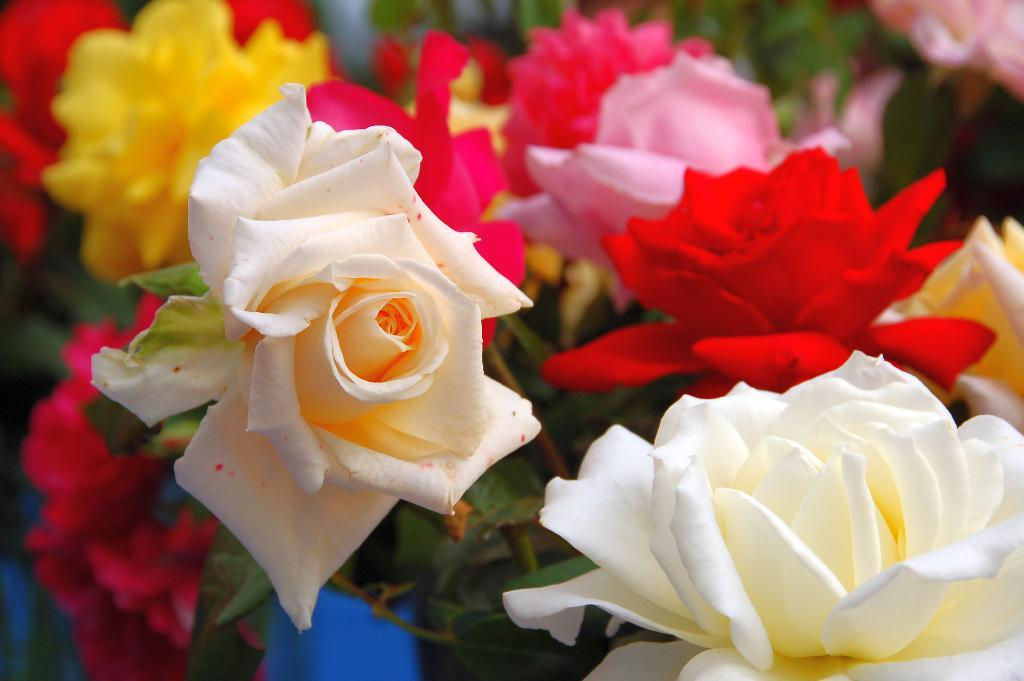What type of plants can be seen in the picture? There are flowers in the picture. What colors are the flowers in the picture? The flowers are white, red, pink, and yellow in color. What type of attention is the box receiving from the flowers in the image? There is no box present in the image, so it cannot receive any attention from the flowers. 